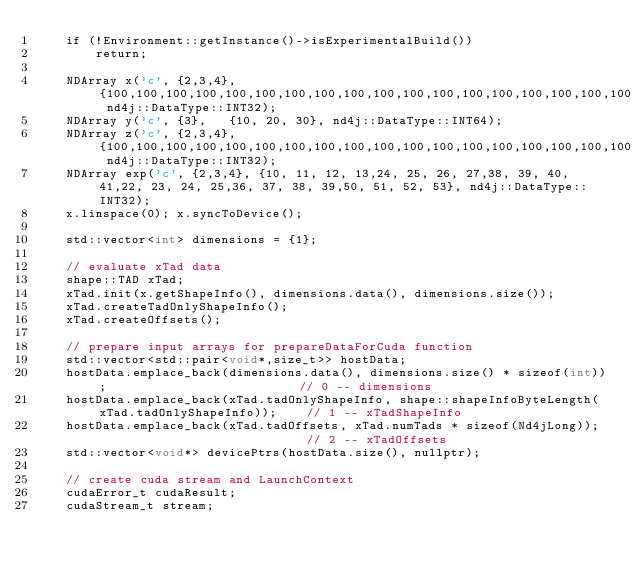Convert code to text. <code><loc_0><loc_0><loc_500><loc_500><_Cuda_>	if (!Environment::getInstance()->isExperimentalBuild())
        return;
    	
	NDArray x('c', {2,3,4}, {100,100,100,100,100,100,100,100,100,100,100,100,100,100,100,100,100,100,100,100,100,100,100,100}, nd4j::DataType::INT32);
    NDArray y('c', {3},   {10, 20, 30}, nd4j::DataType::INT64);
    NDArray z('c', {2,3,4}, {100,100,100,100,100,100,100,100,100,100,100,100,100,100,100,100,100,100,100,100,100,100,100,100}, nd4j::DataType::INT32);	
	NDArray exp('c', {2,3,4}, {10, 11, 12, 13,24, 25, 26, 27,38, 39, 40, 41,22, 23, 24, 25,36, 37, 38, 39,50, 51, 52, 53}, nd4j::DataType::INT32);
	x.linspace(0); x.syncToDevice();

    std::vector<int> dimensions = {1};

    // evaluate xTad data 
    shape::TAD xTad;
    xTad.init(x.getShapeInfo(), dimensions.data(), dimensions.size());
    xTad.createTadOnlyShapeInfo();
    xTad.createOffsets();

    // prepare input arrays for prepareDataForCuda function       
    std::vector<std::pair<void*,size_t>> hostData;   
	hostData.emplace_back(dimensions.data(), dimensions.size() * sizeof(int));							// 0 -- dimensions
	hostData.emplace_back(xTad.tadOnlyShapeInfo, shape::shapeInfoByteLength(xTad.tadOnlyShapeInfo));	// 1 -- xTadShapeInfo
	hostData.emplace_back(xTad.tadOffsets, xTad.numTads * sizeof(Nd4jLong));							// 2 -- xTadOffsets	
	std::vector<void*> devicePtrs(hostData.size(), nullptr);
	
	// create cuda stream and LaunchContext
	cudaError_t cudaResult;
	cudaStream_t stream;</code> 